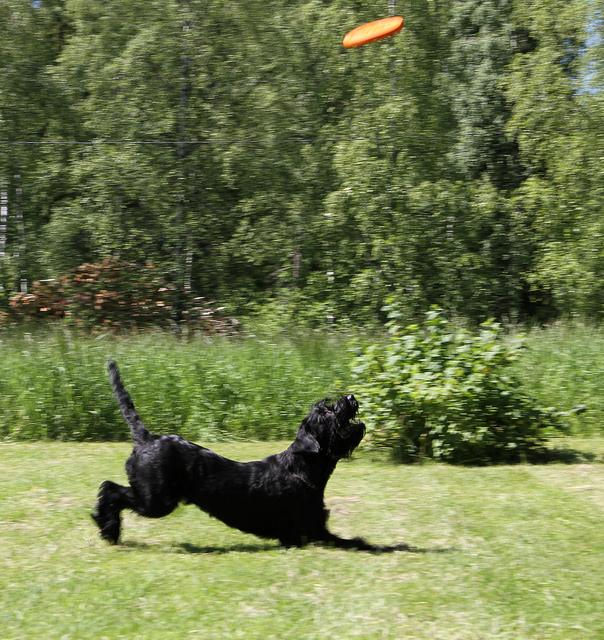Is the dog playing frisbee?
Be succinct. Yes. Does the grass need cutting?
Keep it brief. No. What color is the Frisbee?
Quick response, please. Orange. Is the dog being held back?
Short answer required. No. What type of surface is the dog running on?
Give a very brief answer. Grass. 